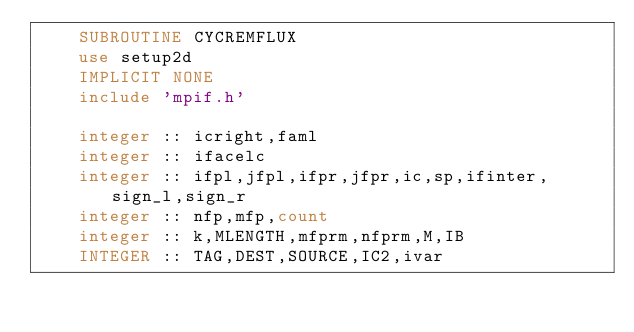<code> <loc_0><loc_0><loc_500><loc_500><_FORTRAN_>    SUBROUTINE CYCREMFLUX
    use setup2d
    IMPLICIT NONE
    include 'mpif.h'
  
    integer :: icright,faml
    integer :: ifacelc
    integer :: ifpl,jfpl,ifpr,jfpr,ic,sp,ifinter,sign_l,sign_r
    integer :: nfp,mfp,count
    integer :: k,MLENGTH,mfprm,nfprm,M,IB
    INTEGER :: TAG,DEST,SOURCE,IC2,ivar</code> 